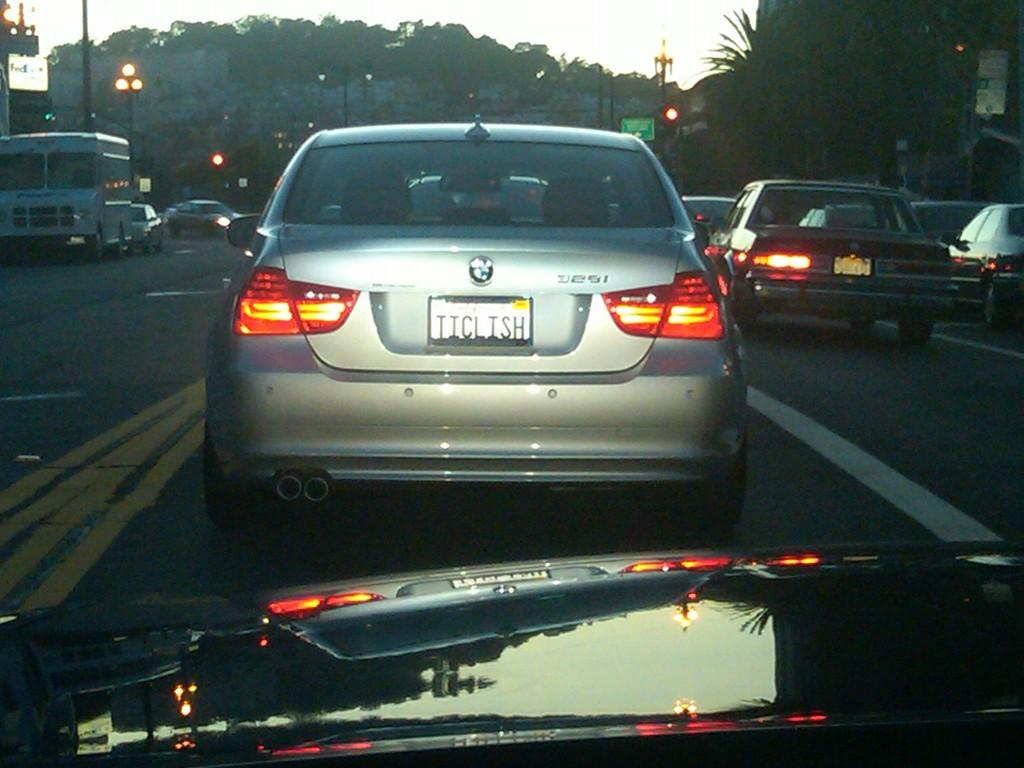<image>
Relay a brief, clear account of the picture shown. A silver BMW liscence plate is TICLISH on the back. 